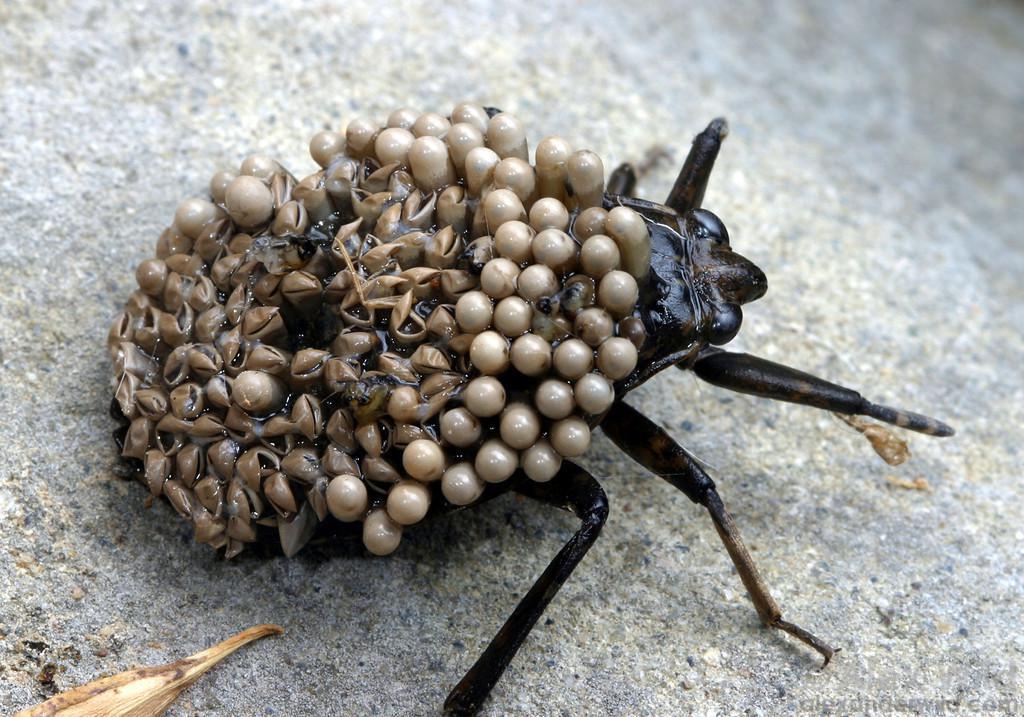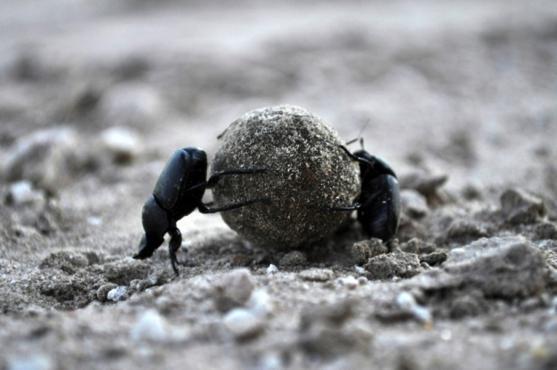The first image is the image on the left, the second image is the image on the right. Assess this claim about the two images: "A dug beetle with a ball of dug is pictured in black and white.". Correct or not? Answer yes or no. No. 